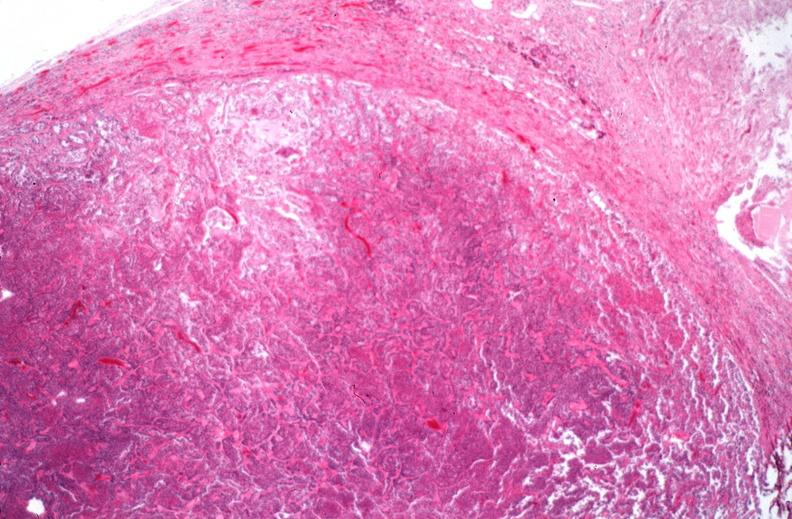s endocrine present?
Answer the question using a single word or phrase. Yes 